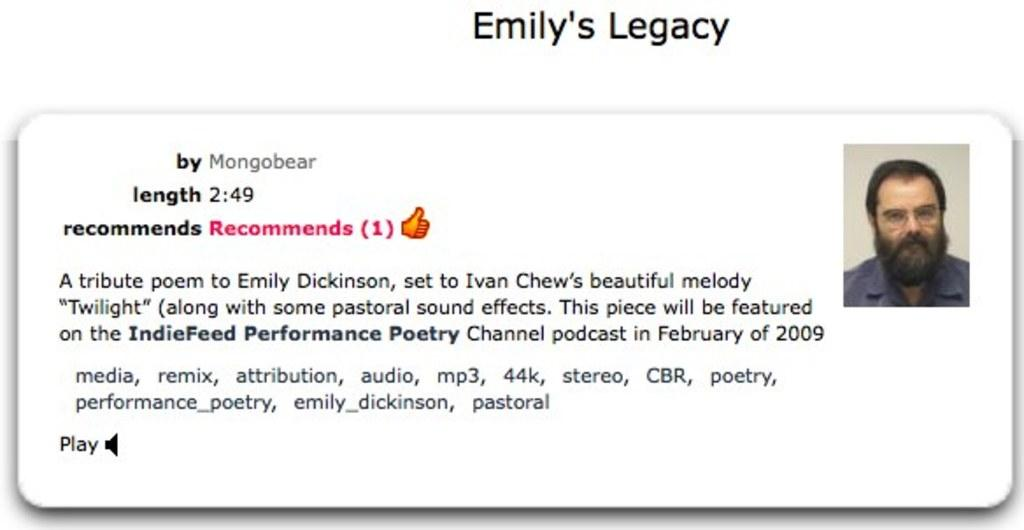What can be found within the image? There is text and an image in the image. Can you describe the text in the image? Unfortunately, the specific content of the text cannot be determined from the provided facts. What is depicted in the image within the image? The content of the image within the image cannot be determined from the provided facts. Can you describe the mint plant growing next to the text in the image? There is no mention of a mint plant in the provided facts, so it cannot be determined if one is present in the image. 